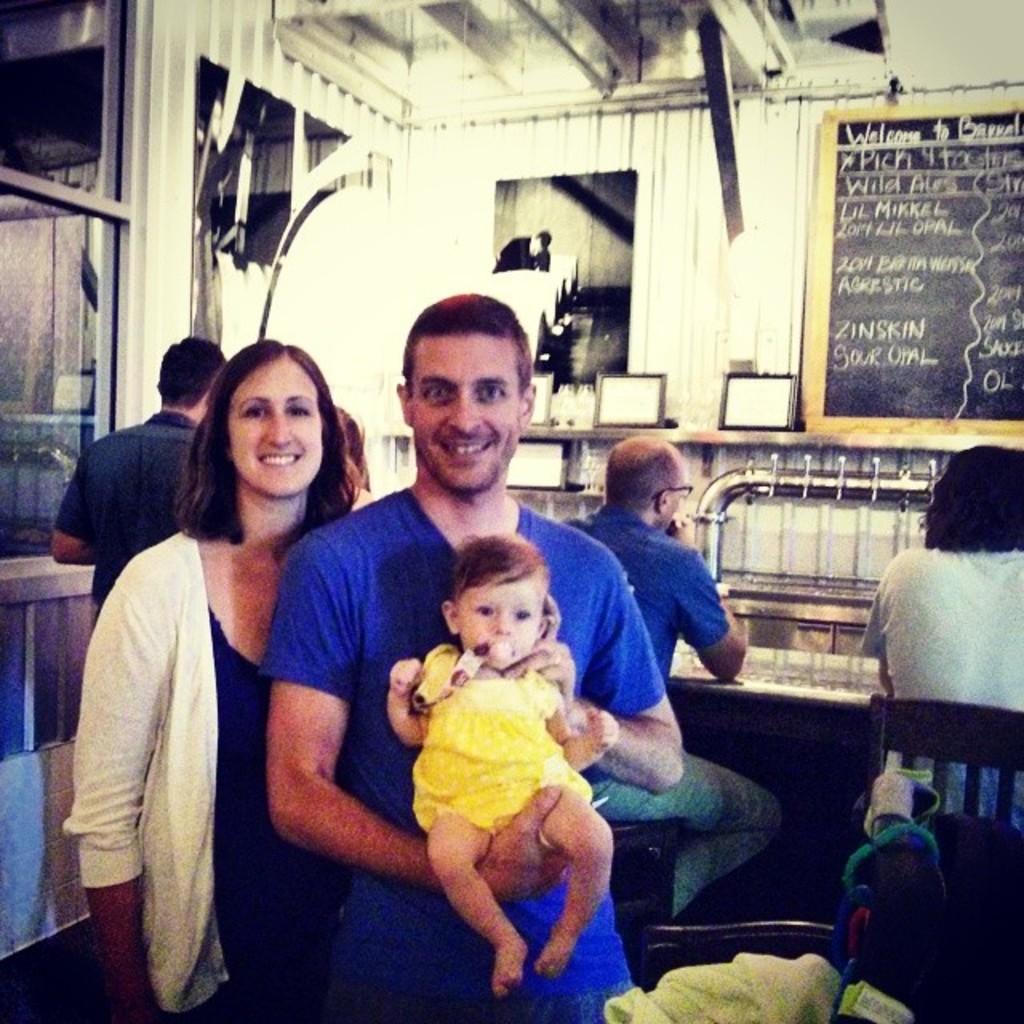Can you describe this image briefly? In this image there is a woman and a man standing, a man is holding a baby in his hands, in the background there are two persons sitting on chairs and two are standing and there is a wall, for that wall there is a board, on that board there is some text. 